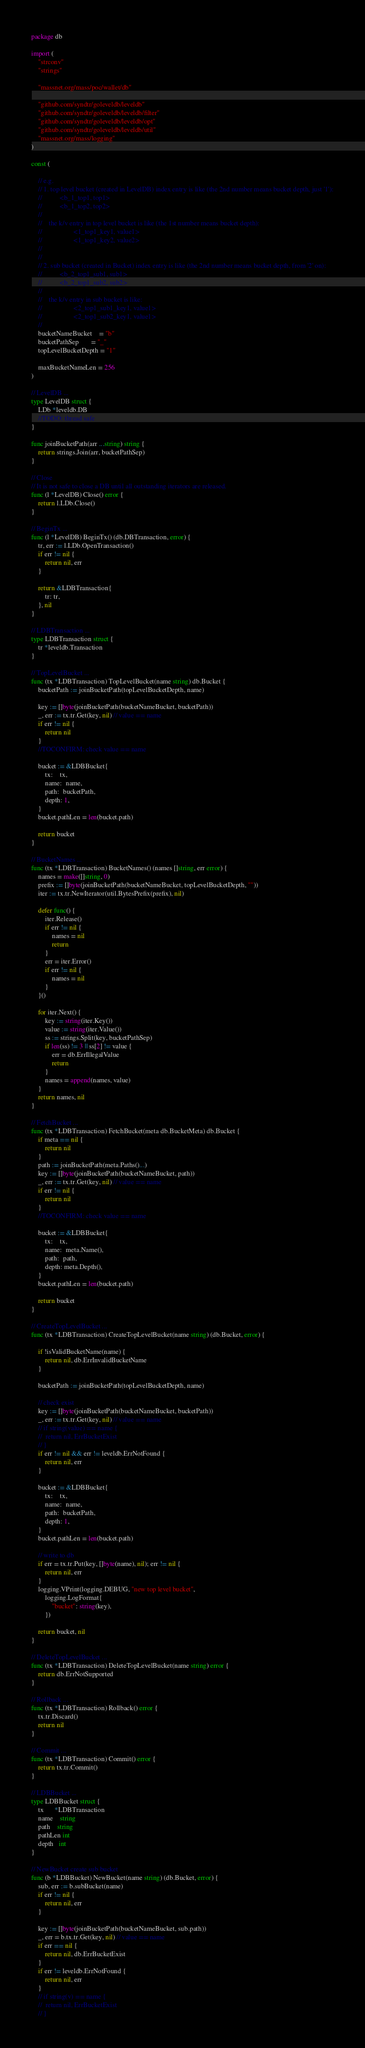Convert code to text. <code><loc_0><loc_0><loc_500><loc_500><_Go_>package db

import (
	"strconv"
	"strings"

	"massnet.org/mass/poc/wallet/db"

	"github.com/syndtr/goleveldb/leveldb"
	"github.com/syndtr/goleveldb/leveldb/filter"
	"github.com/syndtr/goleveldb/leveldb/opt"
	"github.com/syndtr/goleveldb/leveldb/util"
	"massnet.org/mass/logging"
)

const (

	// e.g.
	// 1. top level bucket (created in LevelDB) index entry is like (the 2nd number means bucket depth, just '1'):
	//          <b_1_top1, top1>
	//          <b_1_top2, top2>
	//
	//	  the k/v entry in top level bucket is like (the 1st number means bucket depth):
	//					<1_top1_key1, value1>
	//					<1_top1_key2, value2>
	//
	//
	// 2. sub bucket (created in Bucket) index entry is like (the 2nd number means bucket depth, from '2' on):
	//          <b_2_top1_sub1, sub1>
	//          <b_2_top1_sub2, sub2>
	//
	//	  the k/v entry in sub bucket is like:
	//					<2_top1_sub1_key1, value1>
	//					<2_top1_sub2_key1, value1>
	//
	bucketNameBucket    = "b"
	bucketPathSep       = "_"
	topLevelBucketDepth = "1"

	maxBucketNameLen = 256
)

// LevelDB ...
type LevelDB struct {
	LDb *leveldb.DB
	//TODO: thread safe
}

func joinBucketPath(arr ...string) string {
	return strings.Join(arr, bucketPathSep)
}

// Close
// It is not safe to close a DB until all outstanding iterators are released.
func (l *LevelDB) Close() error {
	return l.LDb.Close()
}

// BeginTx ...
func (l *LevelDB) BeginTx() (db.DBTransaction, error) {
	tr, err := l.LDb.OpenTransaction()
	if err != nil {
		return nil, err
	}

	return &LDBTransaction{
		tr: tr,
	}, nil
}

// LDBTransaction ...
type LDBTransaction struct {
	tr *leveldb.Transaction
}

// TopLevelBucket ...
func (tx *LDBTransaction) TopLevelBucket(name string) db.Bucket {
	bucketPath := joinBucketPath(topLevelBucketDepth, name)

	key := []byte(joinBucketPath(bucketNameBucket, bucketPath))
	_, err := tx.tr.Get(key, nil) // value == name
	if err != nil {
		return nil
	}
	//TOCONFIRM: check value == name

	bucket := &LDBBucket{
		tx:    tx,
		name:  name,
		path:  bucketPath,
		depth: 1,
	}
	bucket.pathLen = len(bucket.path)

	return bucket
}

// BucketNames ...
func (tx *LDBTransaction) BucketNames() (names []string, err error) {
	names = make([]string, 0)
	prefix := []byte(joinBucketPath(bucketNameBucket, topLevelBucketDepth, ""))
	iter := tx.tr.NewIterator(util.BytesPrefix(prefix), nil)

	defer func() {
		iter.Release()
		if err != nil {
			names = nil
			return
		}
		err = iter.Error()
		if err != nil {
			names = nil
		}
	}()

	for iter.Next() {
		key := string(iter.Key())
		value := string(iter.Value())
		ss := strings.Split(key, bucketPathSep)
		if len(ss) != 3 || ss[2] != value {
			err = db.ErrIllegalValue
			return
		}
		names = append(names, value)
	}
	return names, nil
}

// FetchBucket ...
func (tx *LDBTransaction) FetchBucket(meta db.BucketMeta) db.Bucket {
	if meta == nil {
		return nil
	}
	path := joinBucketPath(meta.Paths()...)
	key := []byte(joinBucketPath(bucketNameBucket, path))
	_, err := tx.tr.Get(key, nil) // value == name
	if err != nil {
		return nil
	}
	//TOCONFIRM: check value == name

	bucket := &LDBBucket{
		tx:    tx,
		name:  meta.Name(),
		path:  path,
		depth: meta.Depth(),
	}
	bucket.pathLen = len(bucket.path)

	return bucket
}

// CreateTopLevelBucket ...
func (tx *LDBTransaction) CreateTopLevelBucket(name string) (db.Bucket, error) {

	if !isValidBucketName(name) {
		return nil, db.ErrInvalidBucketName
	}

	bucketPath := joinBucketPath(topLevelBucketDepth, name)

	// check exist
	key := []byte(joinBucketPath(bucketNameBucket, bucketPath))
	_, err := tx.tr.Get(key, nil) // value == name
	// if string(value) == name {
	// 	return nil, ErrBucketExist
	// }
	if err != nil && err != leveldb.ErrNotFound {
		return nil, err
	}

	bucket := &LDBBucket{
		tx:    tx,
		name:  name,
		path:  bucketPath,
		depth: 1,
	}
	bucket.pathLen = len(bucket.path)

	// write to db
	if err = tx.tr.Put(key, []byte(name), nil); err != nil {
		return nil, err
	}
	logging.VPrint(logging.DEBUG, "new top level bucket",
		logging.LogFormat{
			"bucket": string(key),
		})

	return bucket, nil
}

// DeleteTopLevelBucket ...
func (tx *LDBTransaction) DeleteTopLevelBucket(name string) error {
	return db.ErrNotSupported
}

// Rollback ...
func (tx *LDBTransaction) Rollback() error {
	tx.tr.Discard()
	return nil
}

// Commit ...
func (tx *LDBTransaction) Commit() error {
	return tx.tr.Commit()
}

// LDBBucket ...
type LDBBucket struct {
	tx      *LDBTransaction
	name    string
	path    string
	pathLen int
	depth   int
}

// NewBucket create sub bucket
func (b *LDBBucket) NewBucket(name string) (db.Bucket, error) {
	sub, err := b.subBucket(name)
	if err != nil {
		return nil, err
	}

	key := []byte(joinBucketPath(bucketNameBucket, sub.path))
	_, err = b.tx.tr.Get(key, nil) // value == name
	if err == nil {
		return nil, db.ErrBucketExist
	}
	if err != leveldb.ErrNotFound {
		return nil, err
	}
	// if string(v) == name {
	// 	return nil, ErrBucketExist
	// }
</code> 